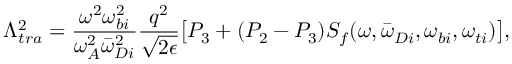<formula> <loc_0><loc_0><loc_500><loc_500>\Lambda _ { t r a } ^ { 2 } = \frac { \omega ^ { 2 } \omega _ { b i } ^ { 2 } } { \omega _ { A } ^ { 2 } { \bar { \omega } } _ { D i } ^ { 2 } } \frac { q ^ { 2 } } { \sqrt { 2 \epsilon } } \left [ P _ { 3 } + ( P _ { 2 } - P _ { 3 } ) { S _ { f } } ( \omega , { \bar { \omega } } _ { D i } , \omega _ { b i } , \omega _ { t i } ) \right ] ,</formula> 